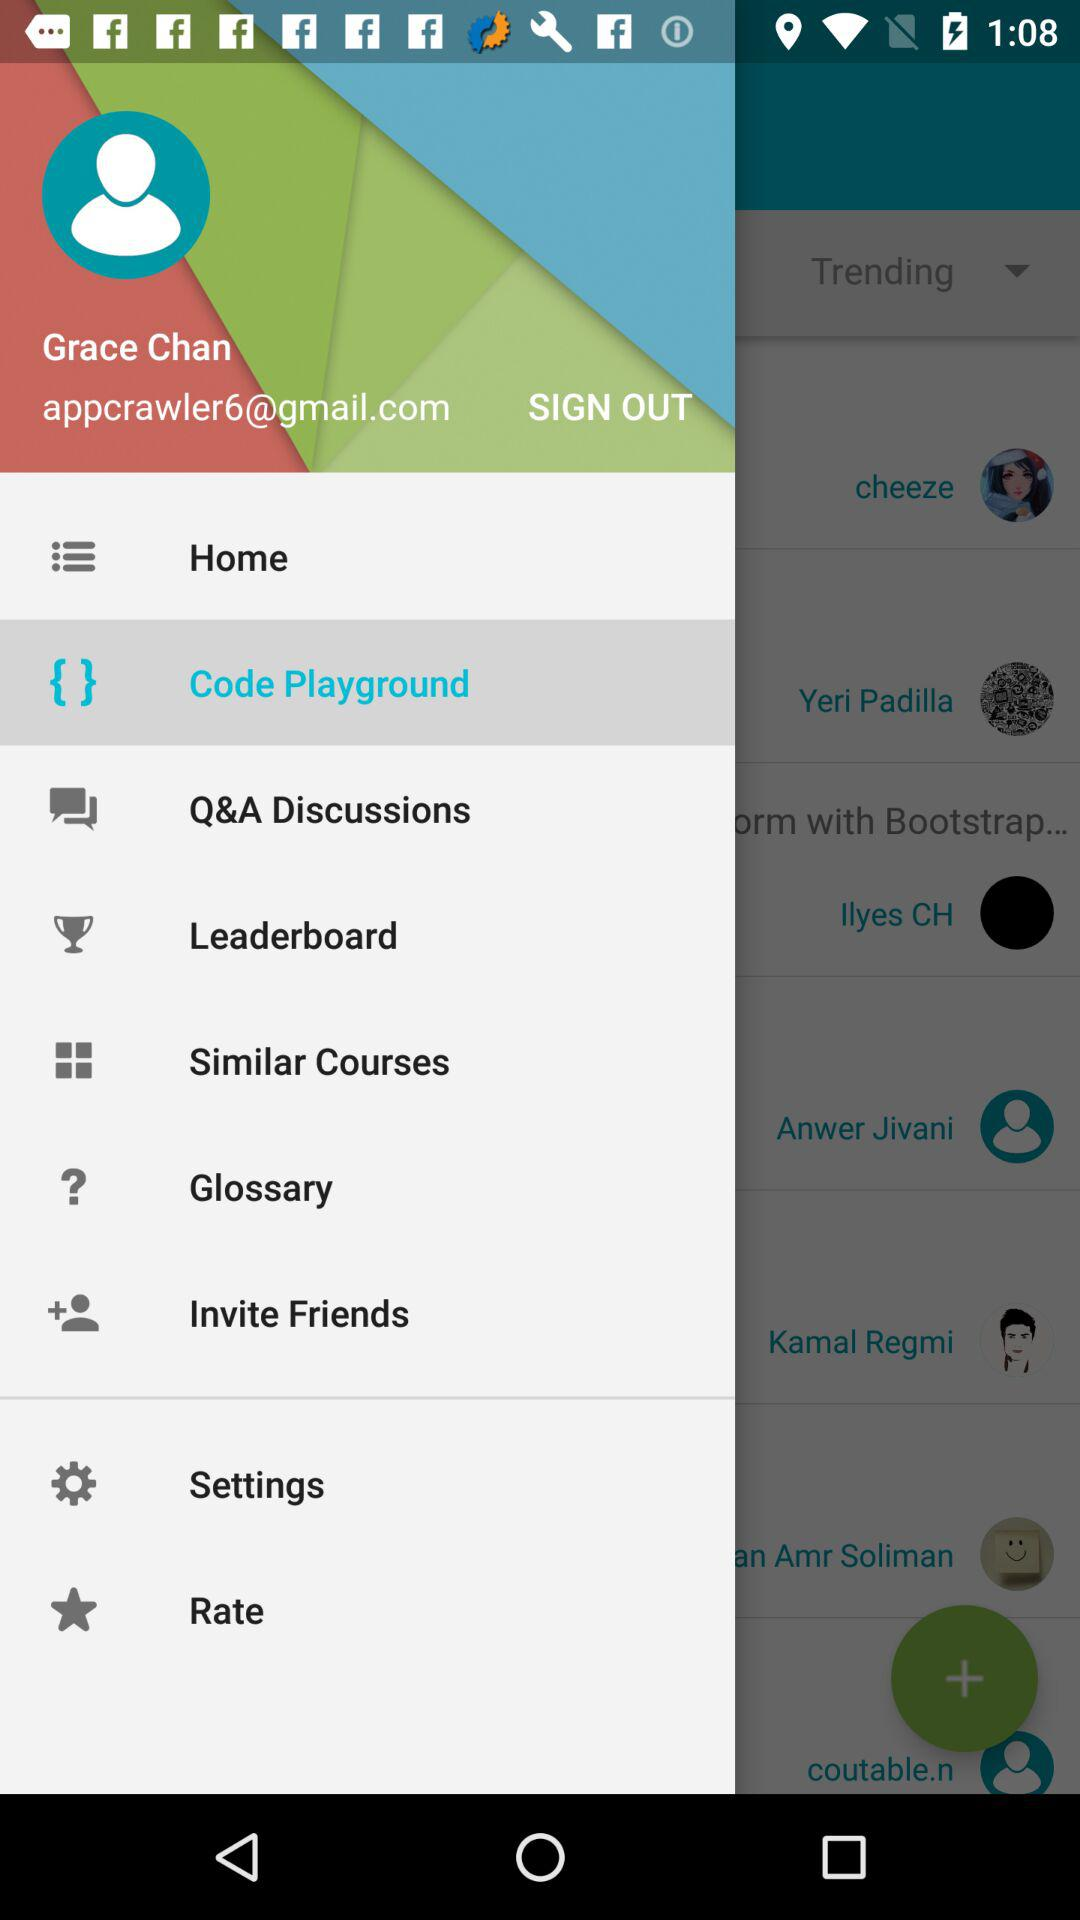What is the name of the user? The name of the user is Grace Chan. 